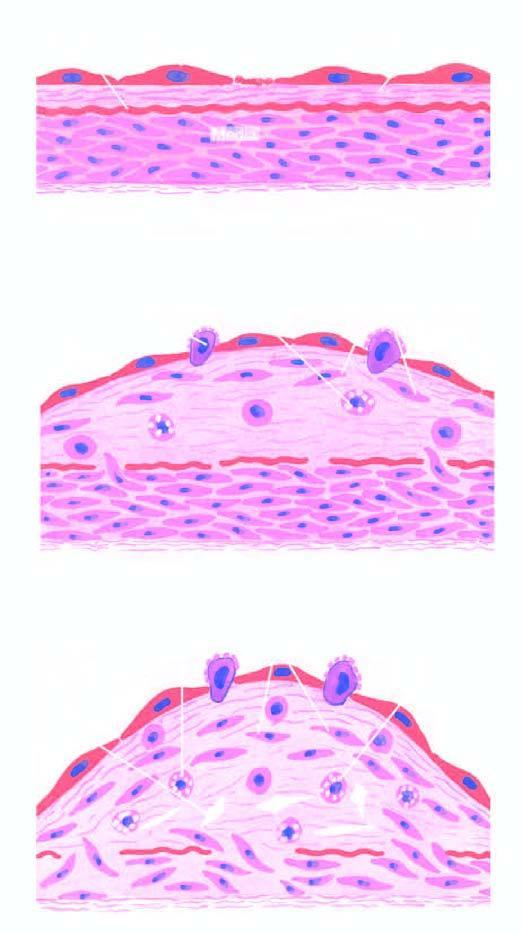s diagrammatic representation of pathogenesis of atherosclerosis as explained by 'reaction-to-injury 'hypothesis?
Answer the question using a single word or phrase. Yes 